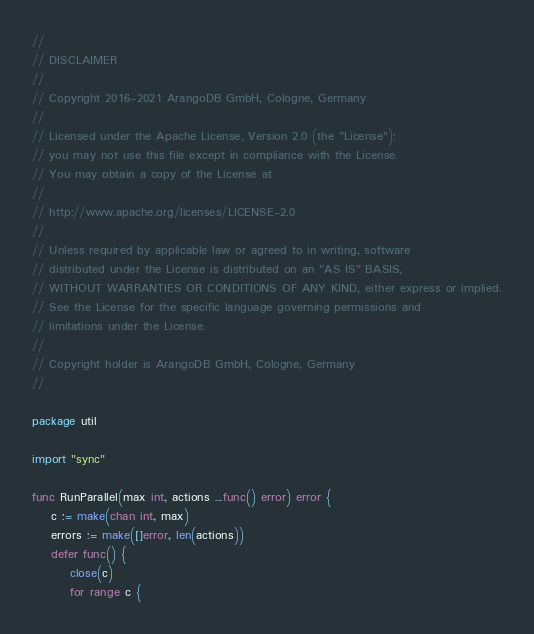Convert code to text. <code><loc_0><loc_0><loc_500><loc_500><_Go_>//
// DISCLAIMER
//
// Copyright 2016-2021 ArangoDB GmbH, Cologne, Germany
//
// Licensed under the Apache License, Version 2.0 (the "License");
// you may not use this file except in compliance with the License.
// You may obtain a copy of the License at
//
// http://www.apache.org/licenses/LICENSE-2.0
//
// Unless required by applicable law or agreed to in writing, software
// distributed under the License is distributed on an "AS IS" BASIS,
// WITHOUT WARRANTIES OR CONDITIONS OF ANY KIND, either express or implied.
// See the License for the specific language governing permissions and
// limitations under the License.
//
// Copyright holder is ArangoDB GmbH, Cologne, Germany
//

package util

import "sync"

func RunParallel(max int, actions ...func() error) error {
	c := make(chan int, max)
	errors := make([]error, len(actions))
	defer func() {
		close(c)
		for range c {</code> 